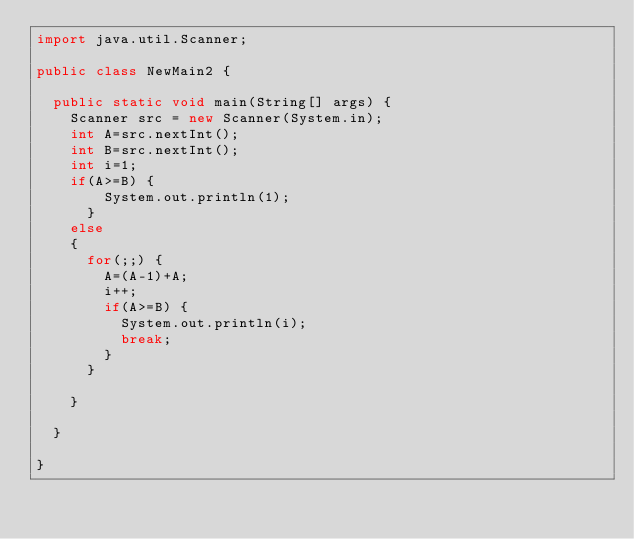Convert code to text. <code><loc_0><loc_0><loc_500><loc_500><_Java_>import java.util.Scanner;

public class NewMain2 {

	public static void main(String[] args) {
		Scanner src = new Scanner(System.in);
		int A=src.nextInt();
		int B=src.nextInt();
		int i=1;
		if(A>=B) {
				System.out.println(1);
			}
		else
		{
			for(;;) {
				A=(A-1)+A;
				i++;
				if(A>=B) {
					System.out.println(i);
					break;
				}
			}
			
		}

	}

}</code> 